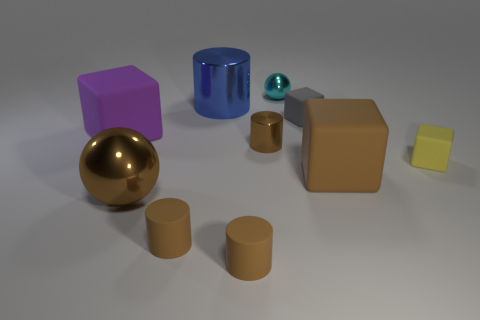Subtract all brown cylinders. How many were subtracted if there are1brown cylinders left? 2 Subtract all brown cylinders. How many cylinders are left? 1 Subtract 1 balls. How many balls are left? 1 Subtract all brown cylinders. How many cylinders are left? 1 Subtract 0 blue blocks. How many objects are left? 10 Subtract all balls. How many objects are left? 8 Subtract all cyan blocks. Subtract all purple cylinders. How many blocks are left? 4 Subtract all cyan cylinders. How many cyan balls are left? 1 Subtract all tiny gray matte objects. Subtract all brown cylinders. How many objects are left? 6 Add 8 blue metal cylinders. How many blue metal cylinders are left? 9 